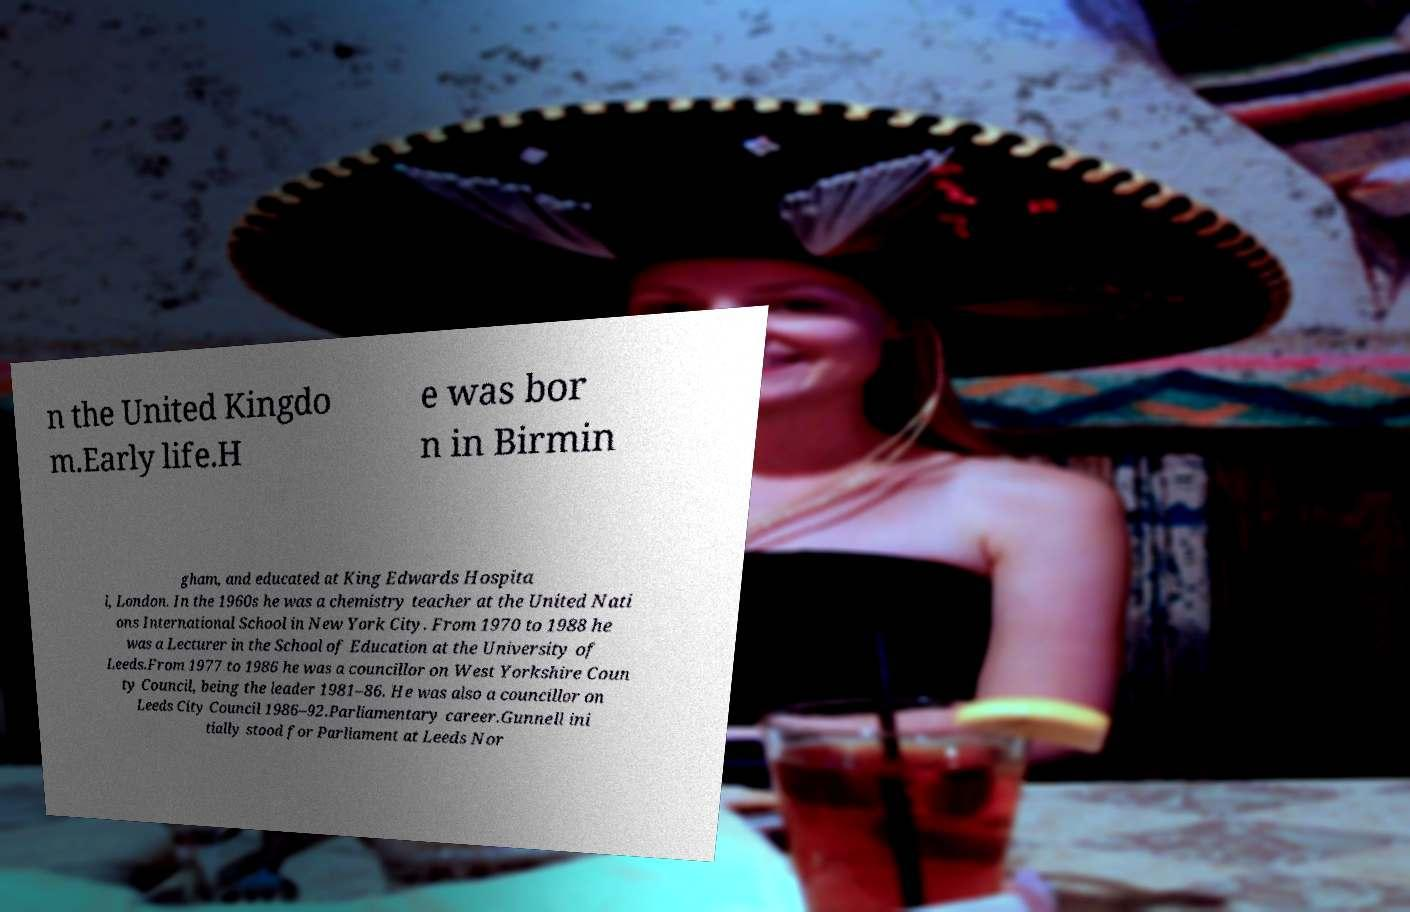What messages or text are displayed in this image? I need them in a readable, typed format. n the United Kingdo m.Early life.H e was bor n in Birmin gham, and educated at King Edwards Hospita l, London. In the 1960s he was a chemistry teacher at the United Nati ons International School in New York City. From 1970 to 1988 he was a Lecturer in the School of Education at the University of Leeds.From 1977 to 1986 he was a councillor on West Yorkshire Coun ty Council, being the leader 1981–86. He was also a councillor on Leeds City Council 1986–92.Parliamentary career.Gunnell ini tially stood for Parliament at Leeds Nor 